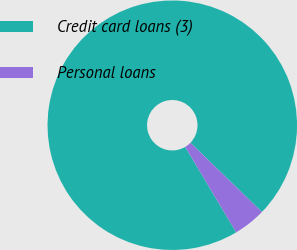<chart> <loc_0><loc_0><loc_500><loc_500><pie_chart><fcel>Credit card loans (3)<fcel>Personal loans<nl><fcel>95.8%<fcel>4.2%<nl></chart> 